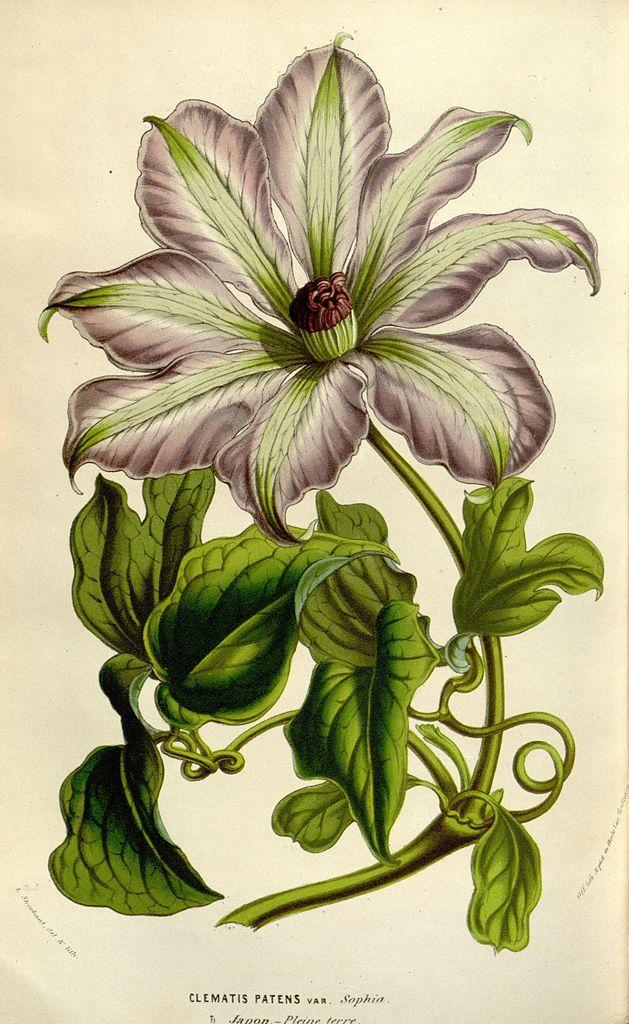What is depicted in the drawing in the image? There is a drawing of a flower in the image. What else can be seen at the bottom of the image? There is text written at the bottom of the image. How many dinosaurs are visible in the image? There are no dinosaurs present in the image. What type of whip is being used in the image? There is no whip present in the image. What song is being sung in the image? There is no indication of a song being sung in the image. 